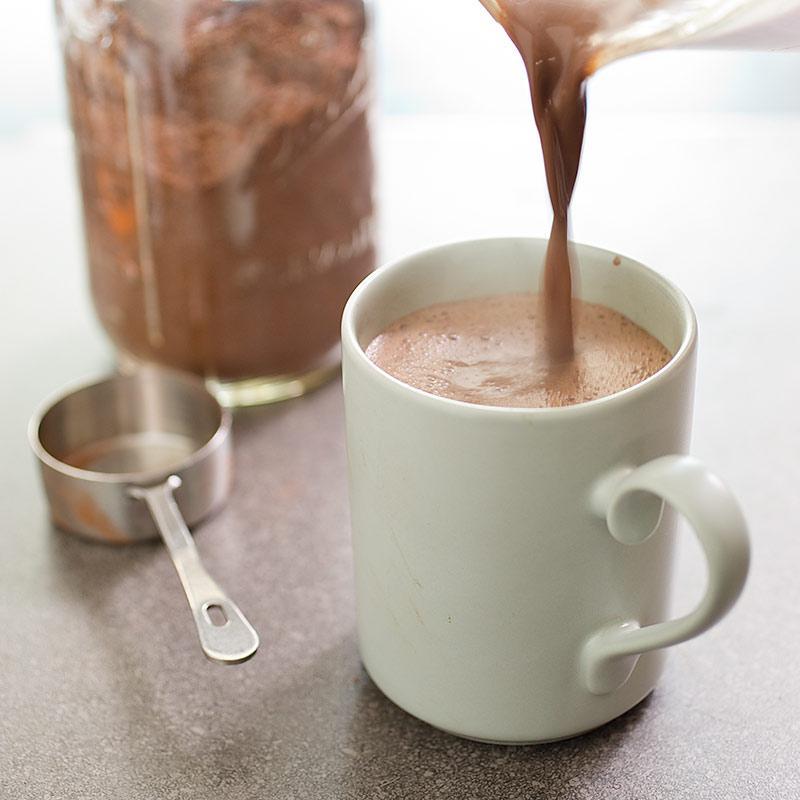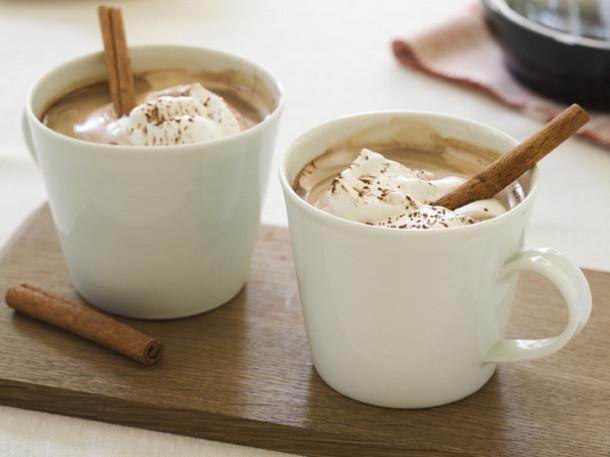The first image is the image on the left, the second image is the image on the right. Examine the images to the left and right. Is the description "Two spoons are visible in the left image." accurate? Answer yes or no. No. The first image is the image on the left, the second image is the image on the right. Examine the images to the left and right. Is the description "The left image features two spoons and two beverages in cups." accurate? Answer yes or no. No. 